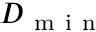Convert formula to latex. <formula><loc_0><loc_0><loc_500><loc_500>D _ { m i n }</formula> 